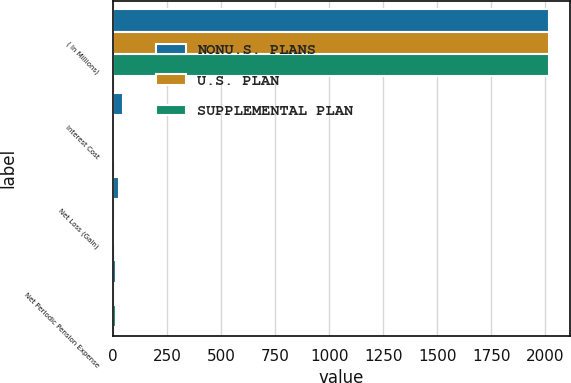<chart> <loc_0><loc_0><loc_500><loc_500><stacked_bar_chart><ecel><fcel>( In Millions)<fcel>Interest Cost<fcel>Net Loss (Gain)<fcel>Net Periodic Pension Expense<nl><fcel>NONU.S. PLANS<fcel>2015<fcel>44.7<fcel>29.7<fcel>15.3<nl><fcel>U.S. PLAN<fcel>2015<fcel>5.7<fcel>1.5<fcel>1.3<nl><fcel>SUPPLEMENTAL PLAN<fcel>2015<fcel>5<fcel>7.3<fcel>16.1<nl></chart> 